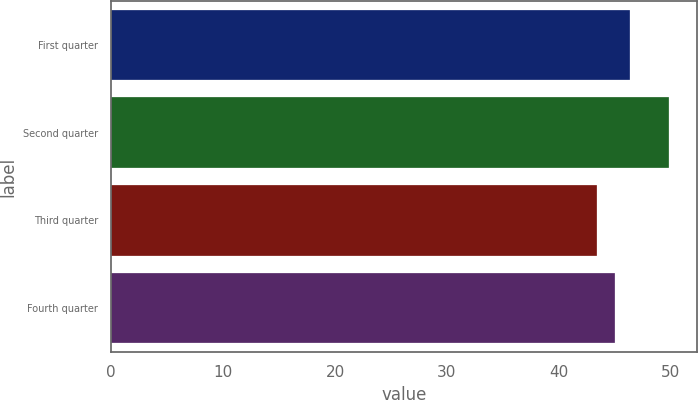Convert chart to OTSL. <chart><loc_0><loc_0><loc_500><loc_500><bar_chart><fcel>First quarter<fcel>Second quarter<fcel>Third quarter<fcel>Fourth quarter<nl><fcel>46.35<fcel>49.8<fcel>43.39<fcel>44.97<nl></chart> 